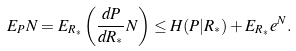<formula> <loc_0><loc_0><loc_500><loc_500>E _ { P } N = E _ { R _ { * } } \left ( \frac { d P } { d R _ { * } } N \right ) \leq H ( P | R _ { * } ) + E _ { R _ { * } } e ^ { N } .</formula> 